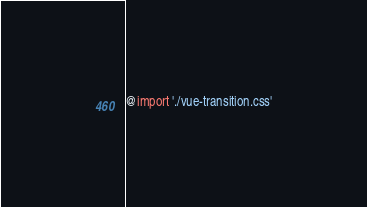Convert code to text. <code><loc_0><loc_0><loc_500><loc_500><_CSS_>@import './vue-transition.css'</code> 